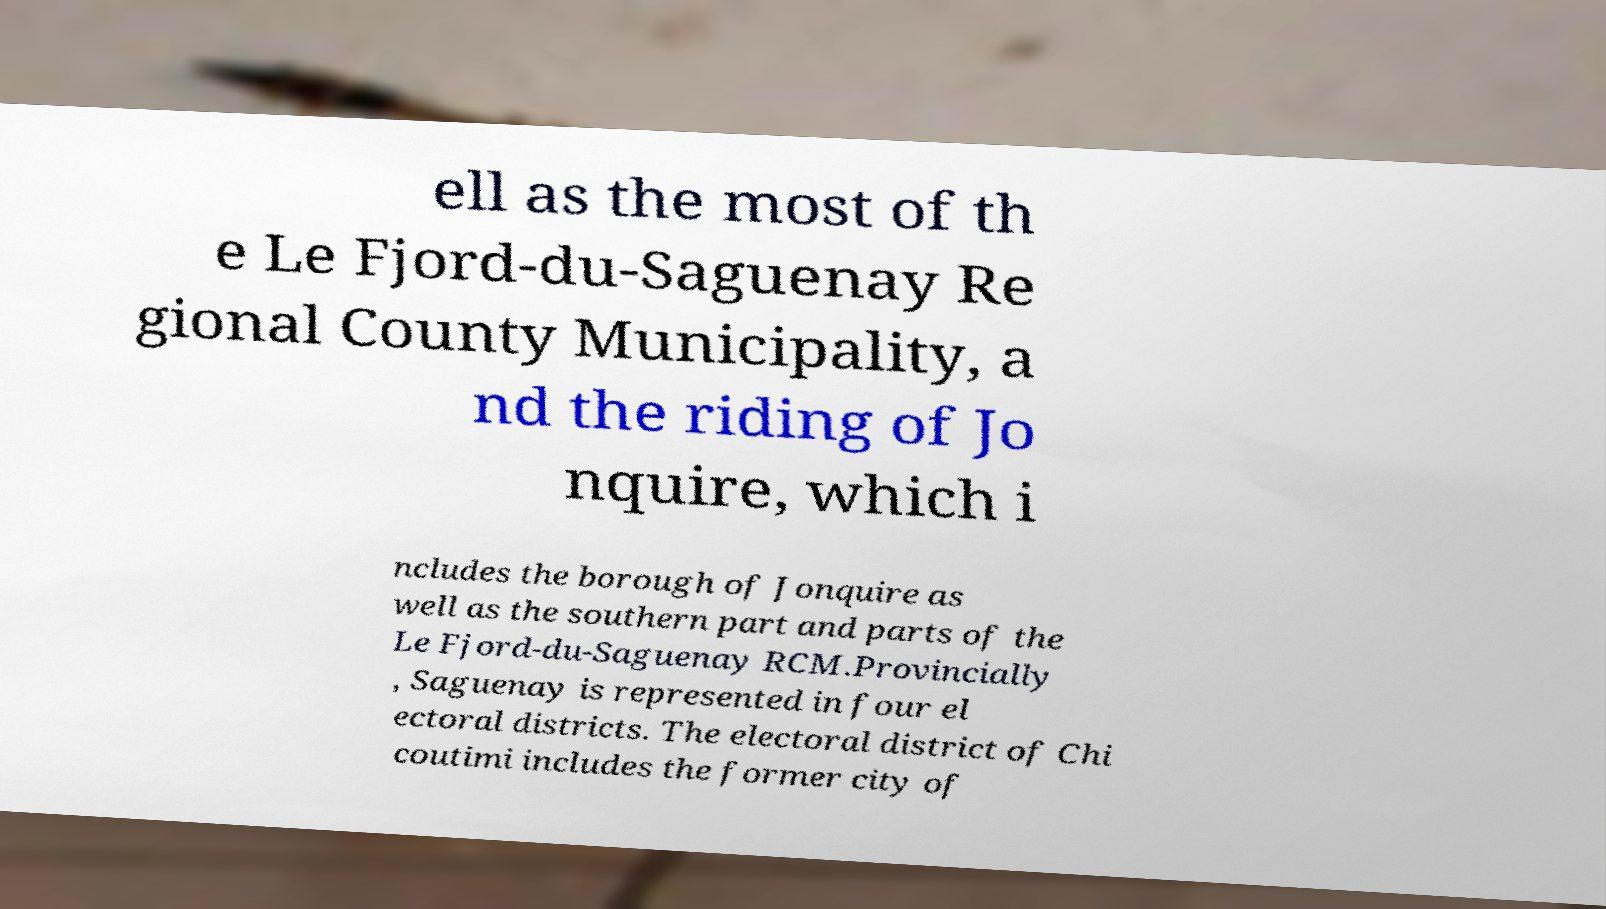What messages or text are displayed in this image? I need them in a readable, typed format. ell as the most of th e Le Fjord-du-Saguenay Re gional County Municipality, a nd the riding of Jo nquire, which i ncludes the borough of Jonquire as well as the southern part and parts of the Le Fjord-du-Saguenay RCM.Provincially , Saguenay is represented in four el ectoral districts. The electoral district of Chi coutimi includes the former city of 